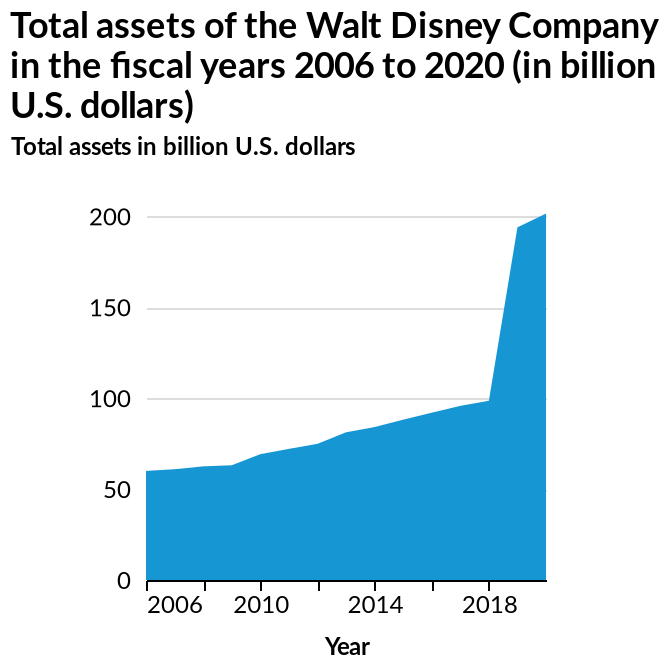<image>
Offer a thorough analysis of the image. The assets steadily increased from 2006 to 2018. Post 2018 the assets rose significantly. Was the increase in Disney's assets between 2018 and 2020 significant?  Yes, there was a steep increase in Disney's assets between 2018 and 2020, amounting to 200 billion dollars. What was the increase in assets owned by Disney between 2018 and 2020?  The increase in assets owned by Disney between 2018 and 2020 was up to 200 billion dollars. 